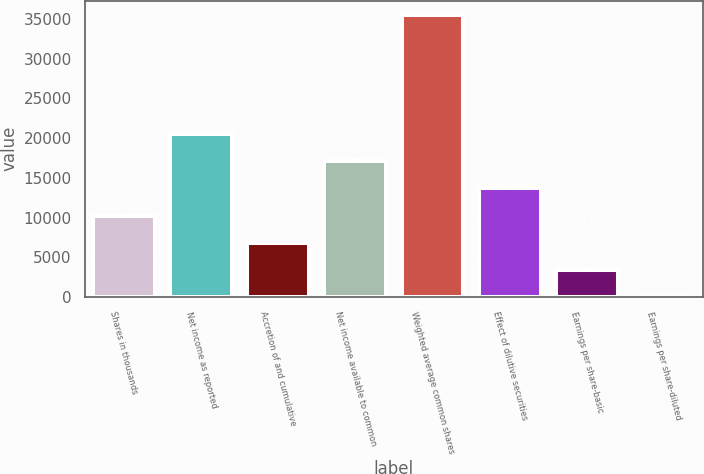<chart> <loc_0><loc_0><loc_500><loc_500><bar_chart><fcel>Shares in thousands<fcel>Net income as reported<fcel>Accretion of and cumulative<fcel>Net income available to common<fcel>Weighted average common shares<fcel>Effect of dilutive securities<fcel>Earnings per share-basic<fcel>Earnings per share-diluted<nl><fcel>10243.9<fcel>20487.7<fcel>6829.32<fcel>17073.1<fcel>35520.6<fcel>13658.5<fcel>3414.74<fcel>0.15<nl></chart> 